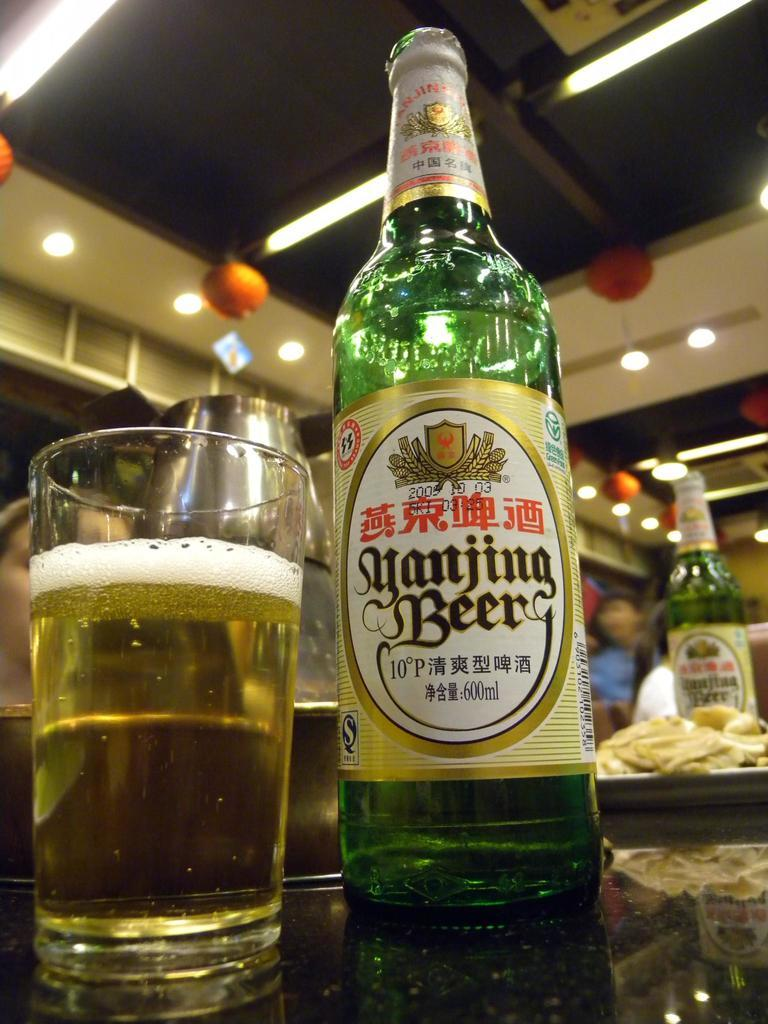<image>
Describe the image concisely. Green bottle of yanjing Beer next to a cup of beer. 